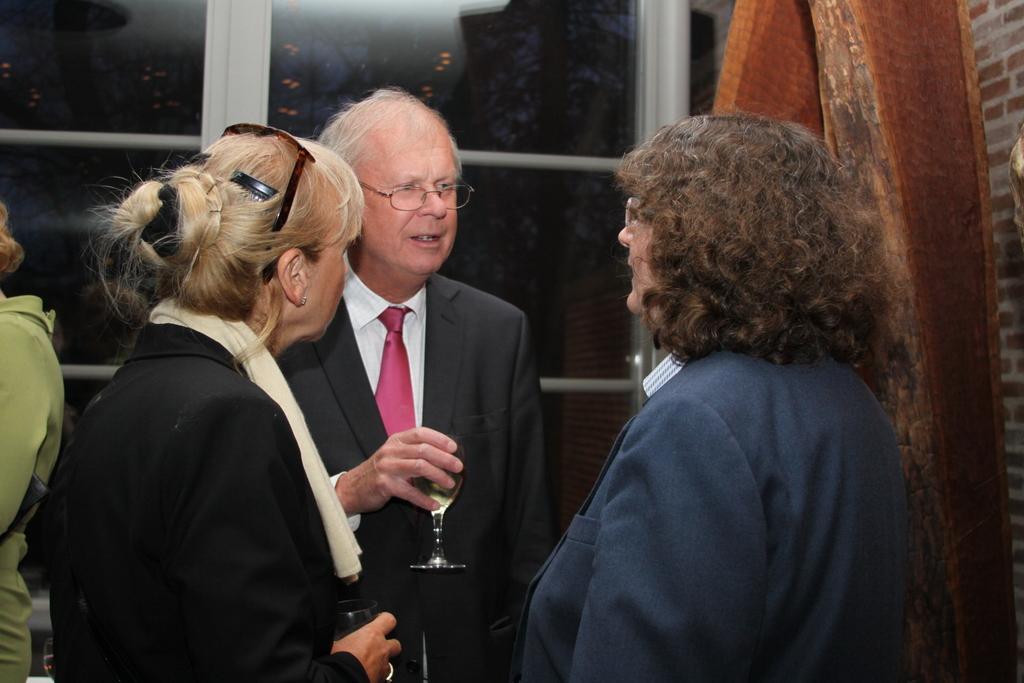In one or two sentences, can you explain what this image depicts? In this picture we can see a group of people standing and some people are holding drinking glasses. Behind the people there are glass windows and a wooden object. 